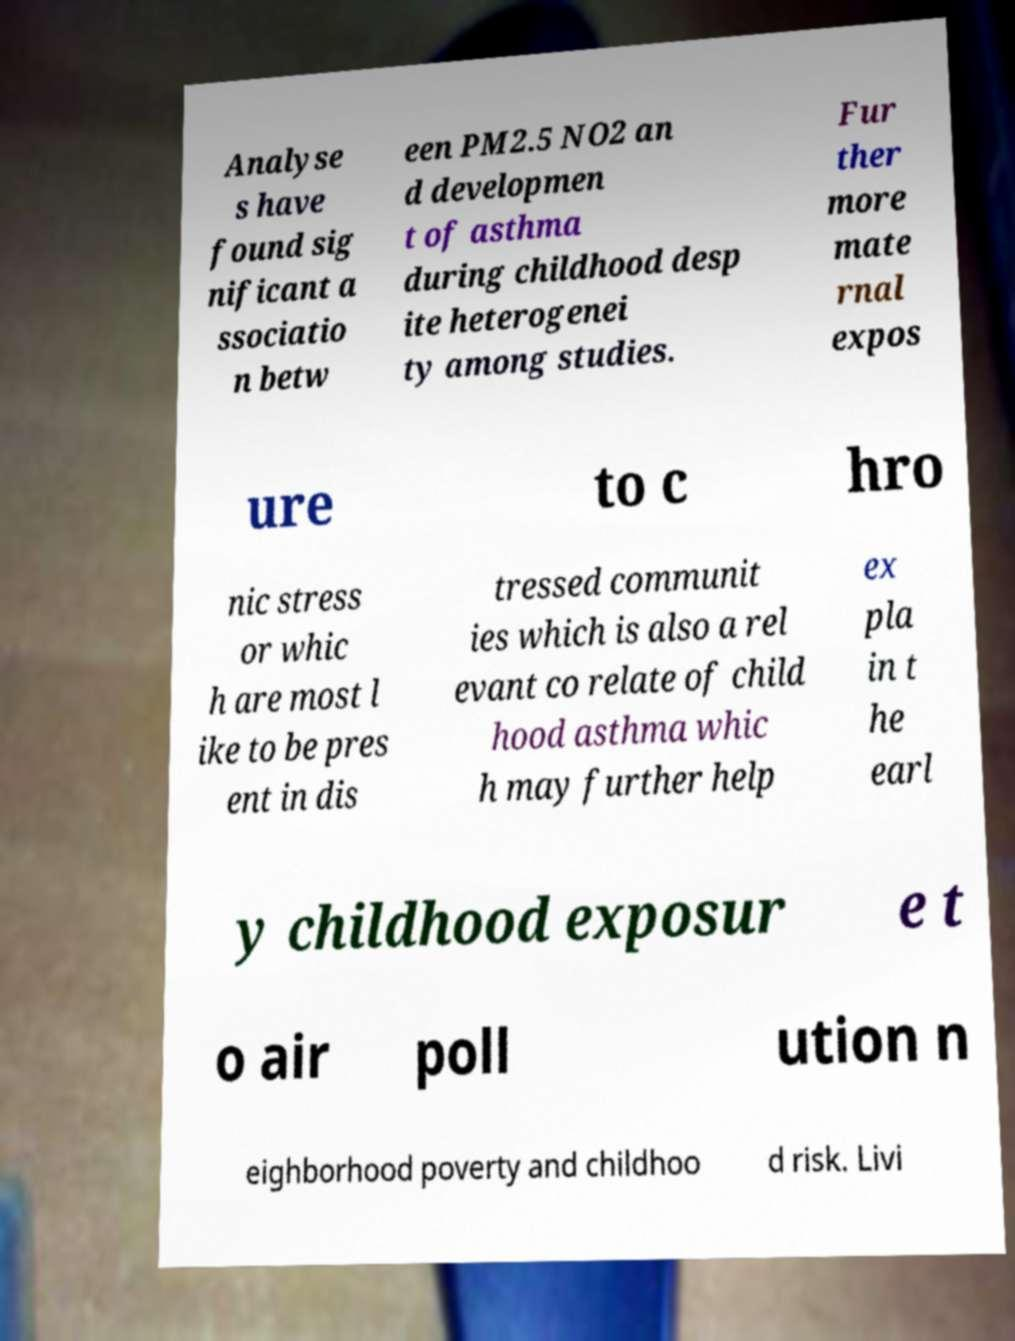Can you accurately transcribe the text from the provided image for me? Analyse s have found sig nificant a ssociatio n betw een PM2.5 NO2 an d developmen t of asthma during childhood desp ite heterogenei ty among studies. Fur ther more mate rnal expos ure to c hro nic stress or whic h are most l ike to be pres ent in dis tressed communit ies which is also a rel evant co relate of child hood asthma whic h may further help ex pla in t he earl y childhood exposur e t o air poll ution n eighborhood poverty and childhoo d risk. Livi 